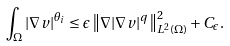<formula> <loc_0><loc_0><loc_500><loc_500>\int _ { \Omega } | \nabla v | ^ { \theta _ { i } } \leq \epsilon \left \| \nabla | \nabla v | ^ { q } \right \| _ { L ^ { 2 } ( \Omega ) } ^ { 2 } + C _ { \epsilon } .</formula> 